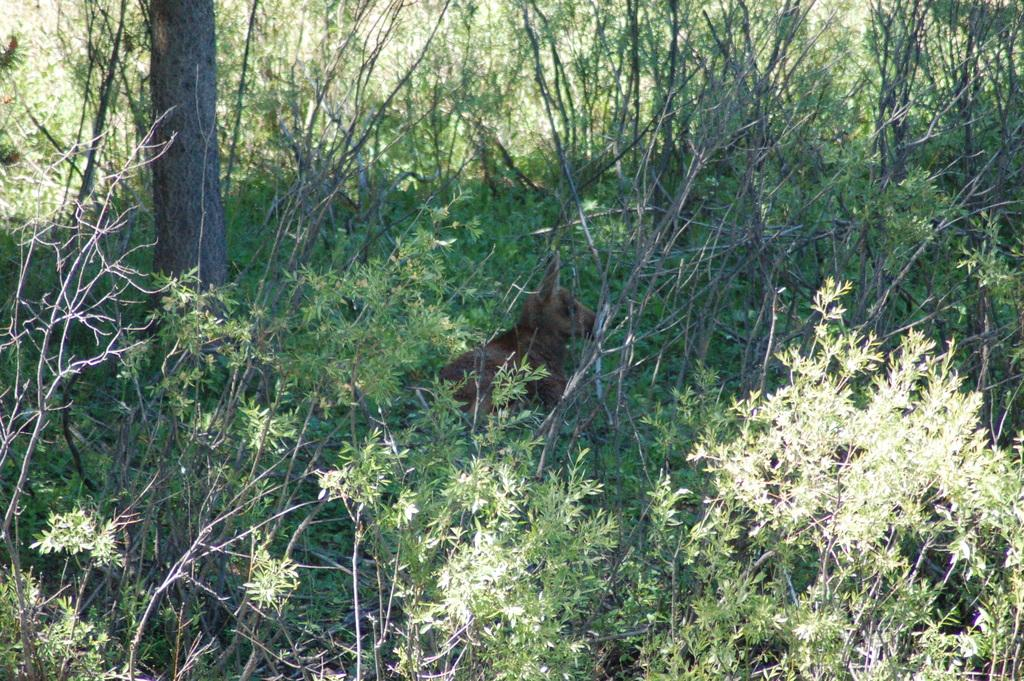What type of animal is in the image? There is an animal in the image, but the specific type cannot be determined from the provided facts. Where is the animal located in the image? The animal is on the ground in the image. What can be seen in the background of the image? There are trees in the background of the image. What is the animal offering to the trees in the image? There is no indication in the image that the animal is offering anything to the trees. 